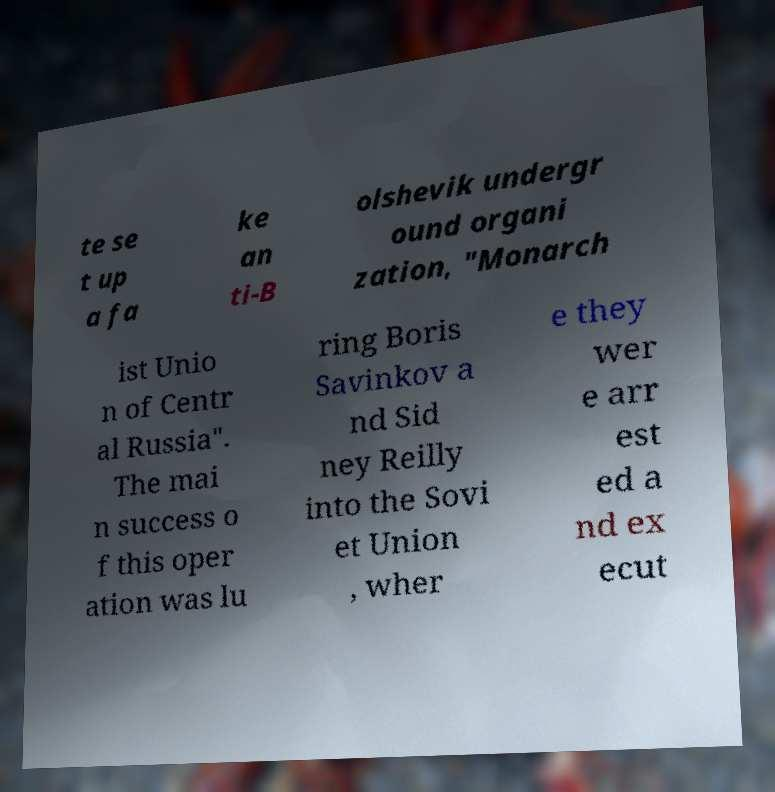Please identify and transcribe the text found in this image. te se t up a fa ke an ti-B olshevik undergr ound organi zation, "Monarch ist Unio n of Centr al Russia". The mai n success o f this oper ation was lu ring Boris Savinkov a nd Sid ney Reilly into the Sovi et Union , wher e they wer e arr est ed a nd ex ecut 